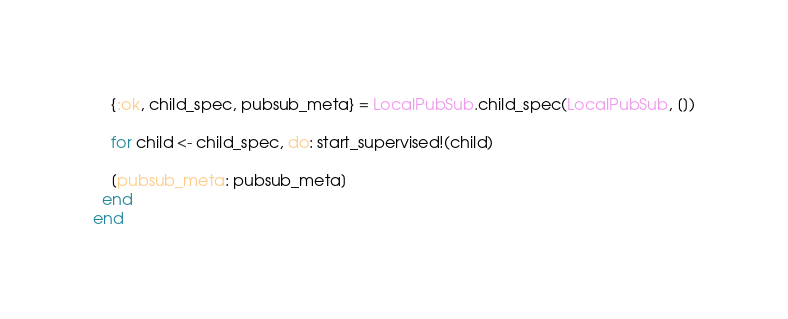Convert code to text. <code><loc_0><loc_0><loc_500><loc_500><_Elixir_>    {:ok, child_spec, pubsub_meta} = LocalPubSub.child_spec(LocalPubSub, [])

    for child <- child_spec, do: start_supervised!(child)

    [pubsub_meta: pubsub_meta]
  end
end
</code> 